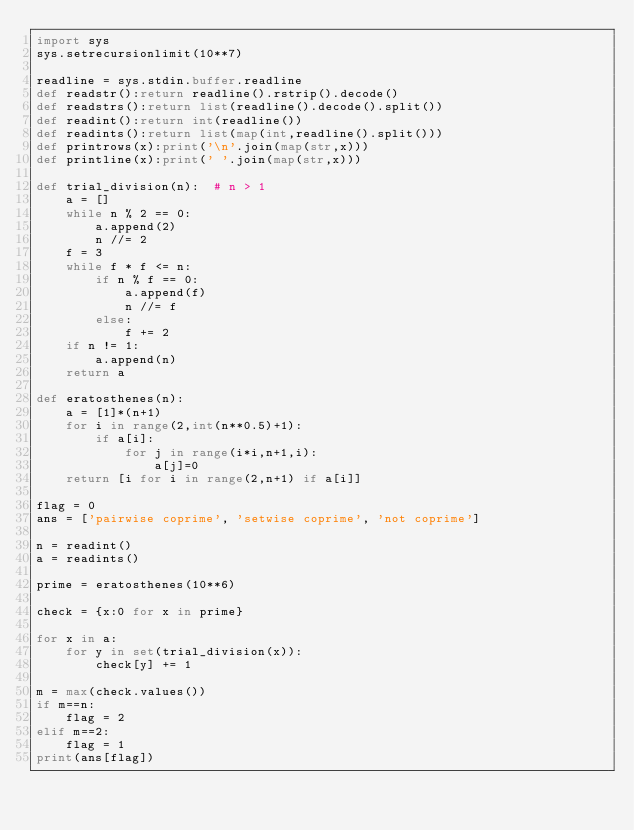Convert code to text. <code><loc_0><loc_0><loc_500><loc_500><_Python_>import sys
sys.setrecursionlimit(10**7)

readline = sys.stdin.buffer.readline
def readstr():return readline().rstrip().decode()
def readstrs():return list(readline().decode().split())
def readint():return int(readline())
def readints():return list(map(int,readline().split()))
def printrows(x):print('\n'.join(map(str,x)))
def printline(x):print(' '.join(map(str,x)))

def trial_division(n):  # n > 1
    a = []
    while n % 2 == 0:
        a.append(2)
        n //= 2
    f = 3
    while f * f <= n:
        if n % f == 0:
            a.append(f)
            n //= f
        else:
            f += 2
    if n != 1:
        a.append(n)
    return a

def eratosthenes(n):
    a = [1]*(n+1)
    for i in range(2,int(n**0.5)+1):
        if a[i]:
            for j in range(i*i,n+1,i):
                a[j]=0
    return [i for i in range(2,n+1) if a[i]]

flag = 0
ans = ['pairwise coprime', 'setwise coprime', 'not coprime']

n = readint()
a = readints()

prime = eratosthenes(10**6)

check = {x:0 for x in prime}

for x in a:
    for y in set(trial_division(x)):
        check[y] += 1

m = max(check.values())
if m==n:
    flag = 2
elif m==2:
    flag = 1
print(ans[flag])
        

</code> 